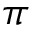Convert formula to latex. <formula><loc_0><loc_0><loc_500><loc_500>\pi</formula> 